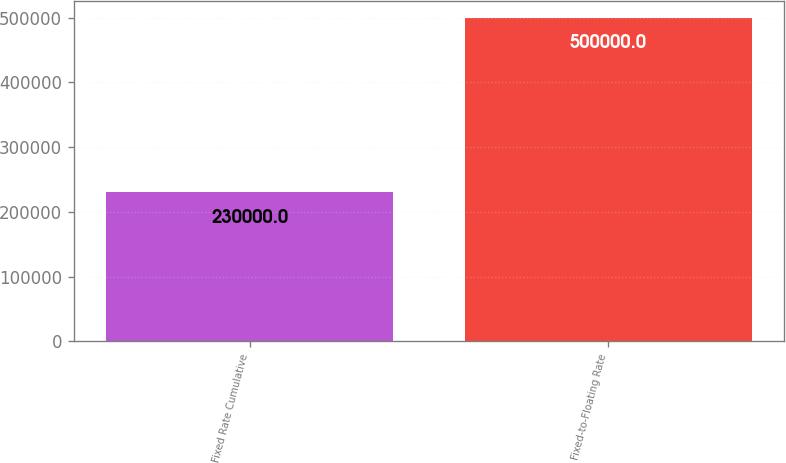<chart> <loc_0><loc_0><loc_500><loc_500><bar_chart><fcel>Fixed Rate Cumulative<fcel>Fixed-to-Floating Rate<nl><fcel>230000<fcel>500000<nl></chart> 